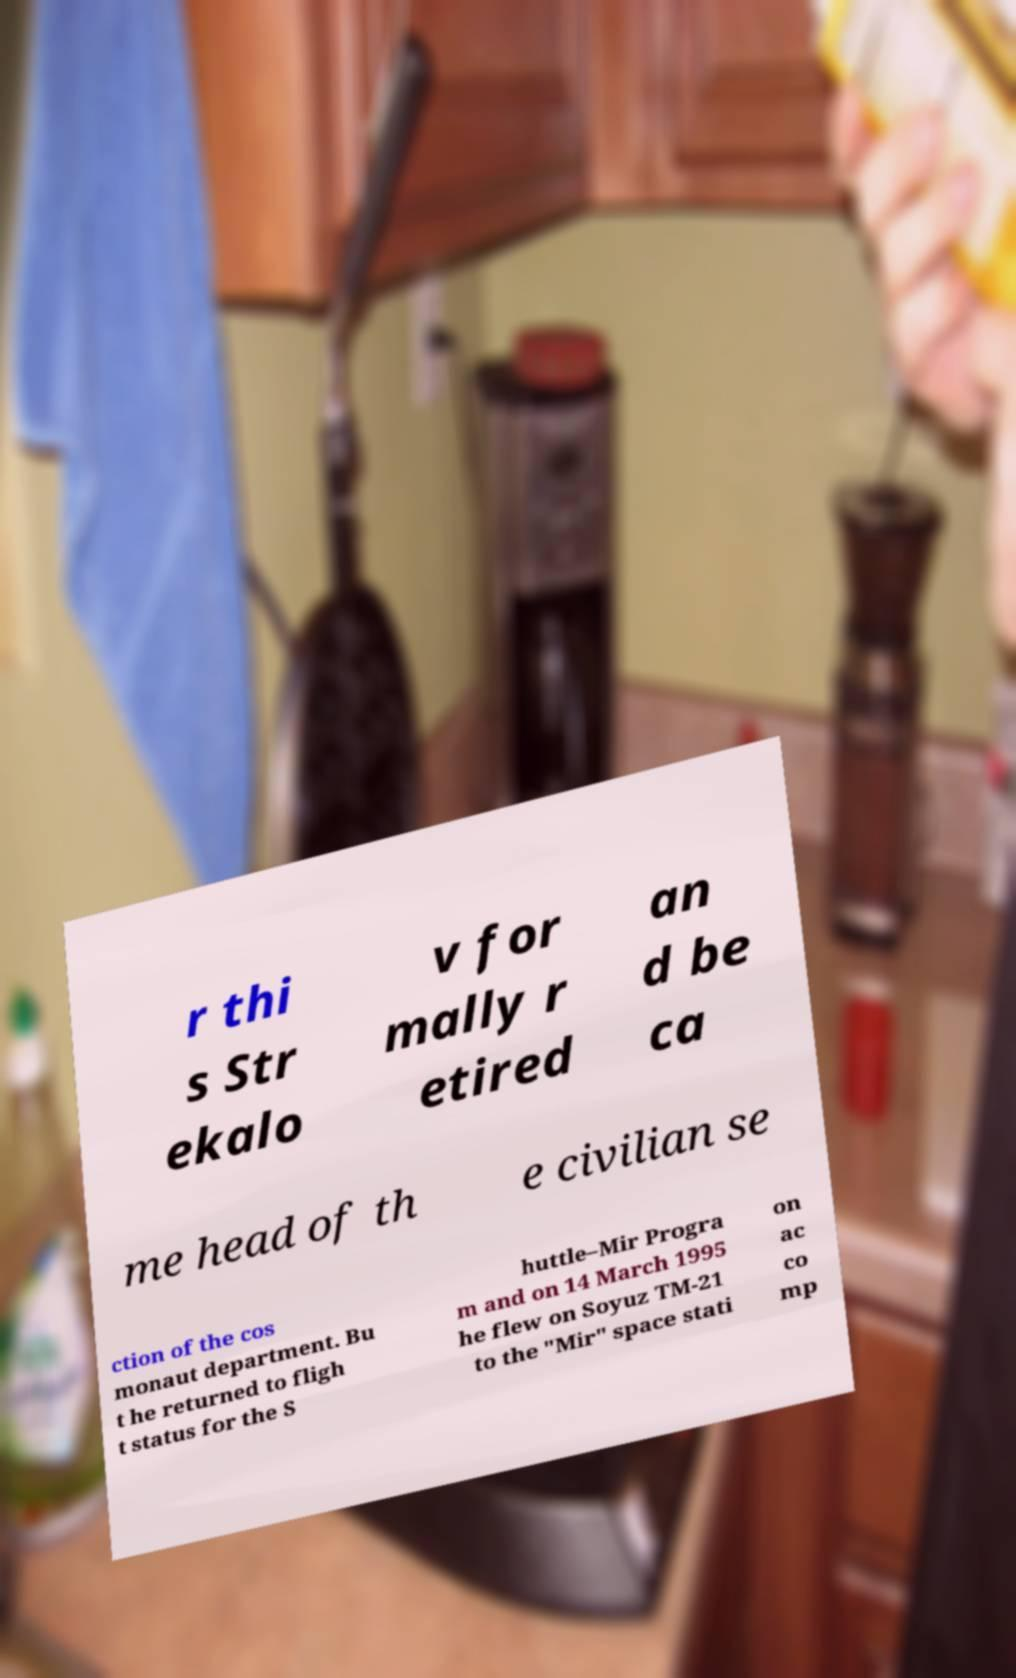Can you read and provide the text displayed in the image?This photo seems to have some interesting text. Can you extract and type it out for me? r thi s Str ekalo v for mally r etired an d be ca me head of th e civilian se ction of the cos monaut department. Bu t he returned to fligh t status for the S huttle–Mir Progra m and on 14 March 1995 he flew on Soyuz TM-21 to the "Mir" space stati on ac co mp 